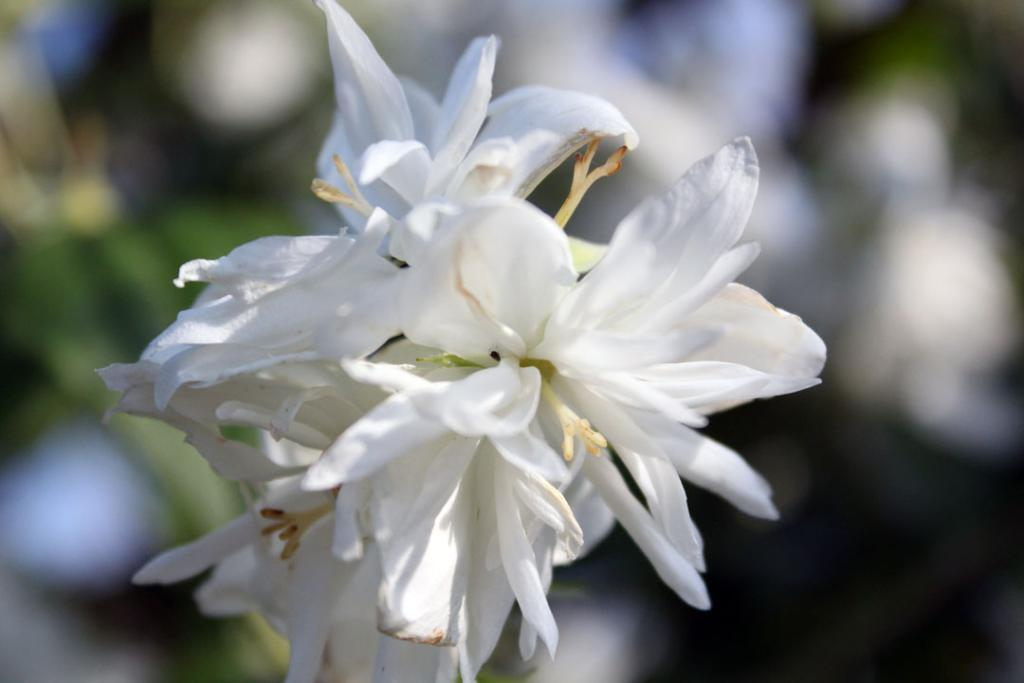What type of flowers are in the image? There is a bunch of white flowers in the image. Can you describe the background of the image? The background of the image is blurred. How does the digestion process of the flowers appear in the image? There is no indication of a digestion process in the image, as it features a bunch of white flowers and a blurred background. 